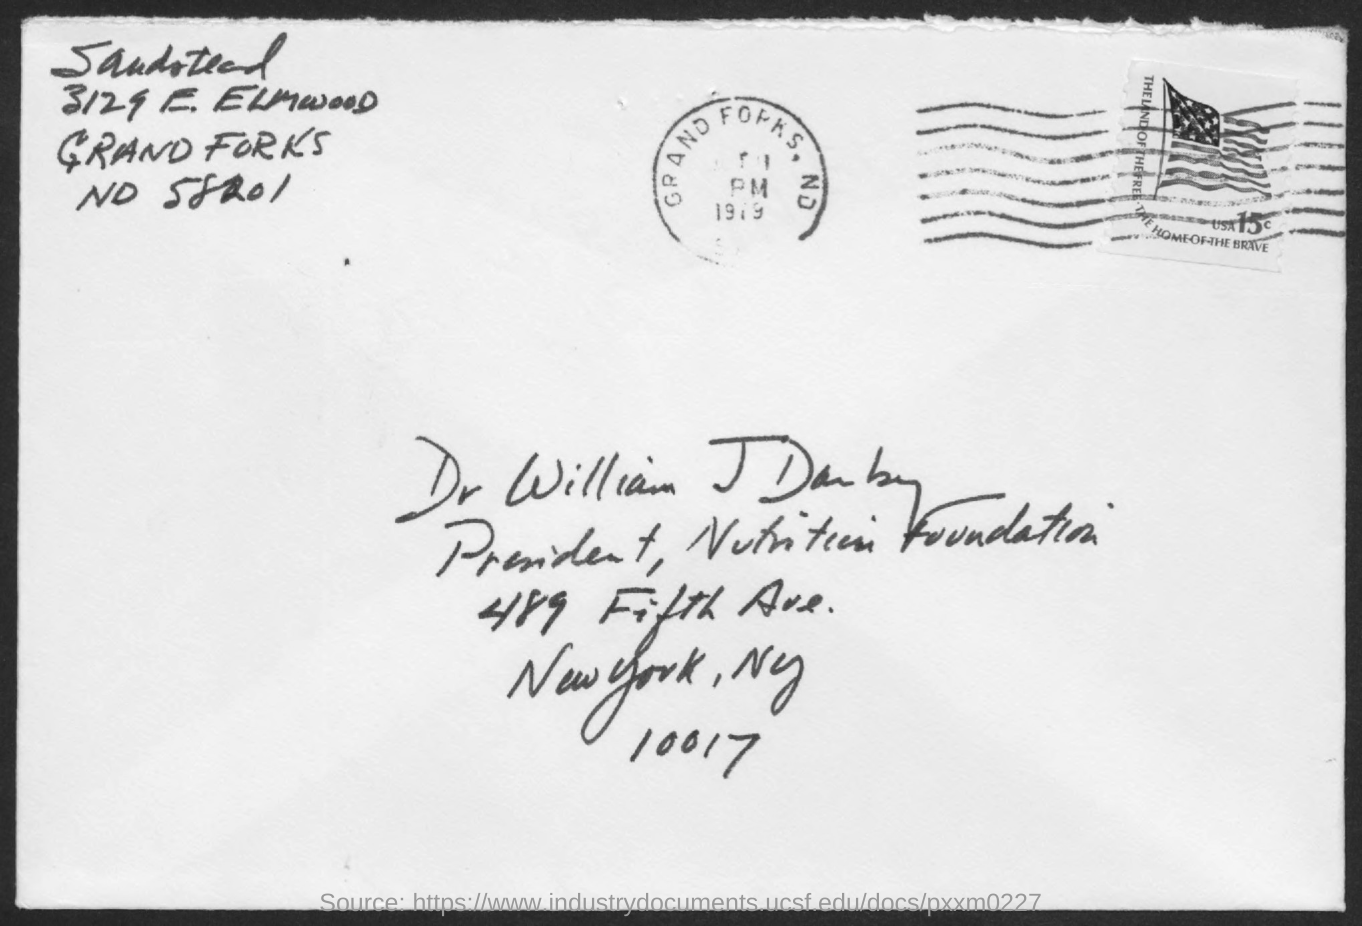Highlight a few significant elements in this photo. The person named in the address is Dr. William J. Darby. William J Darby holds the designation of President at The Nutrition Foundation. 